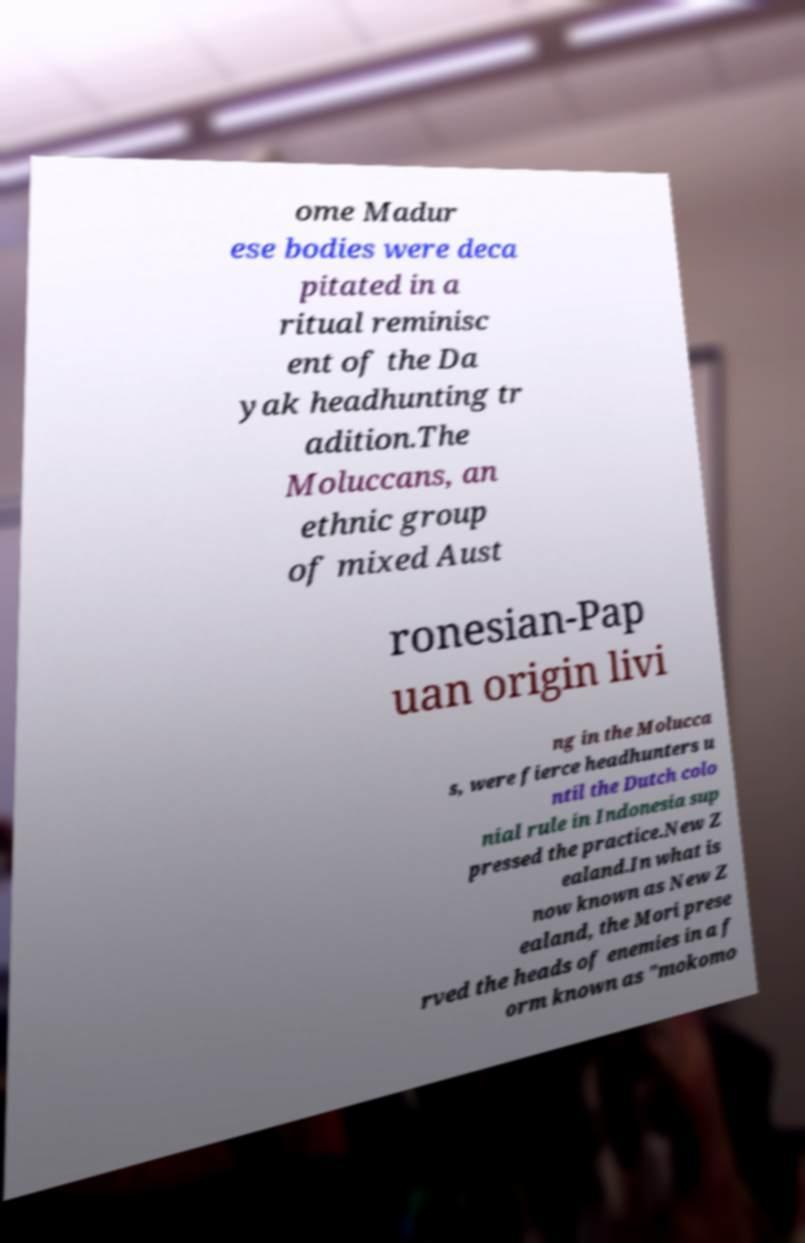I need the written content from this picture converted into text. Can you do that? ome Madur ese bodies were deca pitated in a ritual reminisc ent of the Da yak headhunting tr adition.The Moluccans, an ethnic group of mixed Aust ronesian-Pap uan origin livi ng in the Molucca s, were fierce headhunters u ntil the Dutch colo nial rule in Indonesia sup pressed the practice.New Z ealand.In what is now known as New Z ealand, the Mori prese rved the heads of enemies in a f orm known as "mokomo 